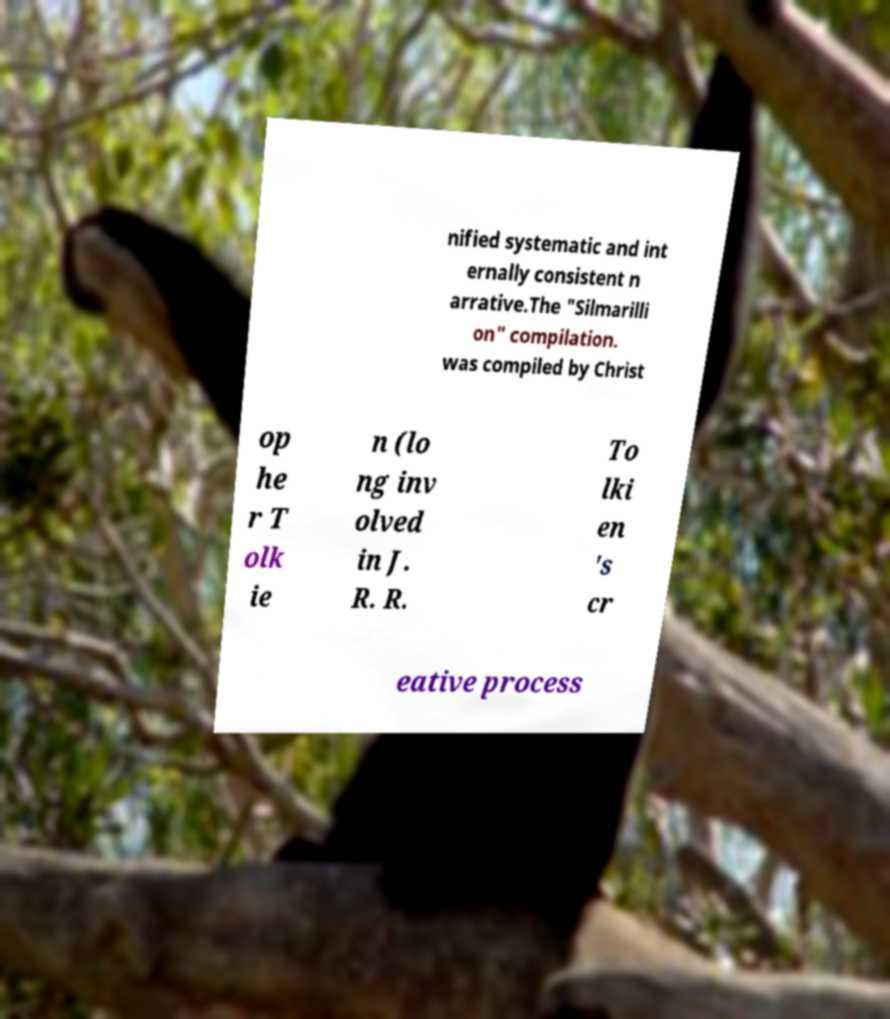Please identify and transcribe the text found in this image. nified systematic and int ernally consistent n arrative.The "Silmarilli on" compilation. was compiled by Christ op he r T olk ie n (lo ng inv olved in J. R. R. To lki en 's cr eative process 